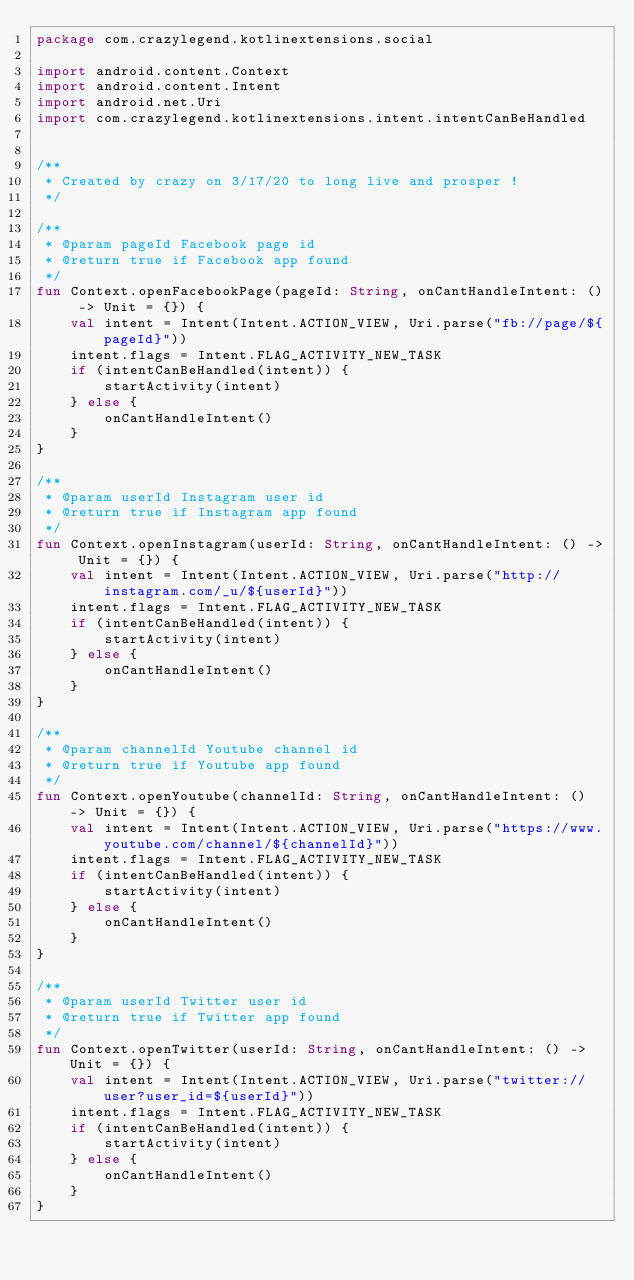<code> <loc_0><loc_0><loc_500><loc_500><_Kotlin_>package com.crazylegend.kotlinextensions.social

import android.content.Context
import android.content.Intent
import android.net.Uri
import com.crazylegend.kotlinextensions.intent.intentCanBeHandled


/**
 * Created by crazy on 3/17/20 to long live and prosper !
 */

/**
 * @param pageId Facebook page id
 * @return true if Facebook app found
 */
fun Context.openFacebookPage(pageId: String, onCantHandleIntent: () -> Unit = {}) {
    val intent = Intent(Intent.ACTION_VIEW, Uri.parse("fb://page/${pageId}"))
    intent.flags = Intent.FLAG_ACTIVITY_NEW_TASK
    if (intentCanBeHandled(intent)) {
        startActivity(intent)
    } else {
        onCantHandleIntent()
    }
}

/**
 * @param userId Instagram user id
 * @return true if Instagram app found
 */
fun Context.openInstagram(userId: String, onCantHandleIntent: () -> Unit = {}) {
    val intent = Intent(Intent.ACTION_VIEW, Uri.parse("http://instagram.com/_u/${userId}"))
    intent.flags = Intent.FLAG_ACTIVITY_NEW_TASK
    if (intentCanBeHandled(intent)) {
        startActivity(intent)
    } else {
        onCantHandleIntent()
    }
}

/**
 * @param channelId Youtube channel id
 * @return true if Youtube app found
 */
fun Context.openYoutube(channelId: String, onCantHandleIntent: () -> Unit = {}) {
    val intent = Intent(Intent.ACTION_VIEW, Uri.parse("https://www.youtube.com/channel/${channelId}"))
    intent.flags = Intent.FLAG_ACTIVITY_NEW_TASK
    if (intentCanBeHandled(intent)) {
        startActivity(intent)
    } else {
        onCantHandleIntent()
    }
}

/**
 * @param userId Twitter user id
 * @return true if Twitter app found
 */
fun Context.openTwitter(userId: String, onCantHandleIntent: () -> Unit = {}) {
    val intent = Intent(Intent.ACTION_VIEW, Uri.parse("twitter://user?user_id=${userId}"))
    intent.flags = Intent.FLAG_ACTIVITY_NEW_TASK
    if (intentCanBeHandled(intent)) {
        startActivity(intent)
    } else {
        onCantHandleIntent()
    }
}</code> 